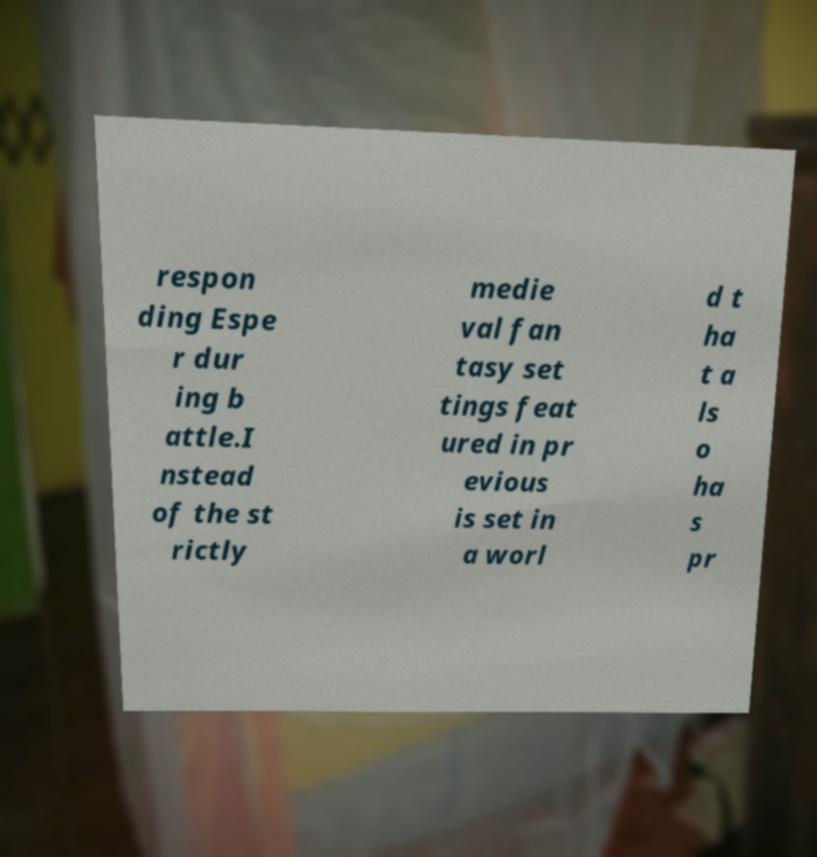What messages or text are displayed in this image? I need them in a readable, typed format. respon ding Espe r dur ing b attle.I nstead of the st rictly medie val fan tasy set tings feat ured in pr evious is set in a worl d t ha t a ls o ha s pr 